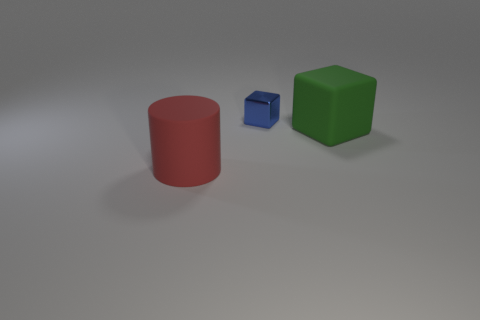What is the size of the green rubber thing that is the same shape as the blue metallic object?
Offer a very short reply. Large. Are there more large things to the left of the large green object than large rubber cylinders behind the tiny blue metal thing?
Make the answer very short. Yes. What number of other things are the same size as the red rubber thing?
Your answer should be compact. 1. What size is the cube that is on the left side of the block to the right of the metallic cube?
Ensure brevity in your answer.  Small. How many tiny objects are shiny cubes or matte cylinders?
Offer a very short reply. 1. There is a thing that is behind the rubber object on the right side of the cube that is behind the green matte cube; how big is it?
Provide a succinct answer. Small. Is there any other thing of the same color as the matte cube?
Give a very brief answer. No. There is a small blue object to the right of the large thing that is left of the matte object on the right side of the blue shiny thing; what is its material?
Ensure brevity in your answer.  Metal. Is the red object the same shape as the tiny blue object?
Ensure brevity in your answer.  No. Is there anything else that is made of the same material as the small blue thing?
Offer a terse response. No. 